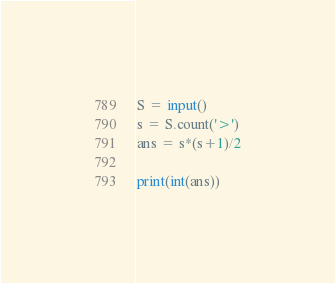<code> <loc_0><loc_0><loc_500><loc_500><_Python_>S = input()
s = S.count('>')
ans = s*(s+1)/2

print(int(ans))</code> 